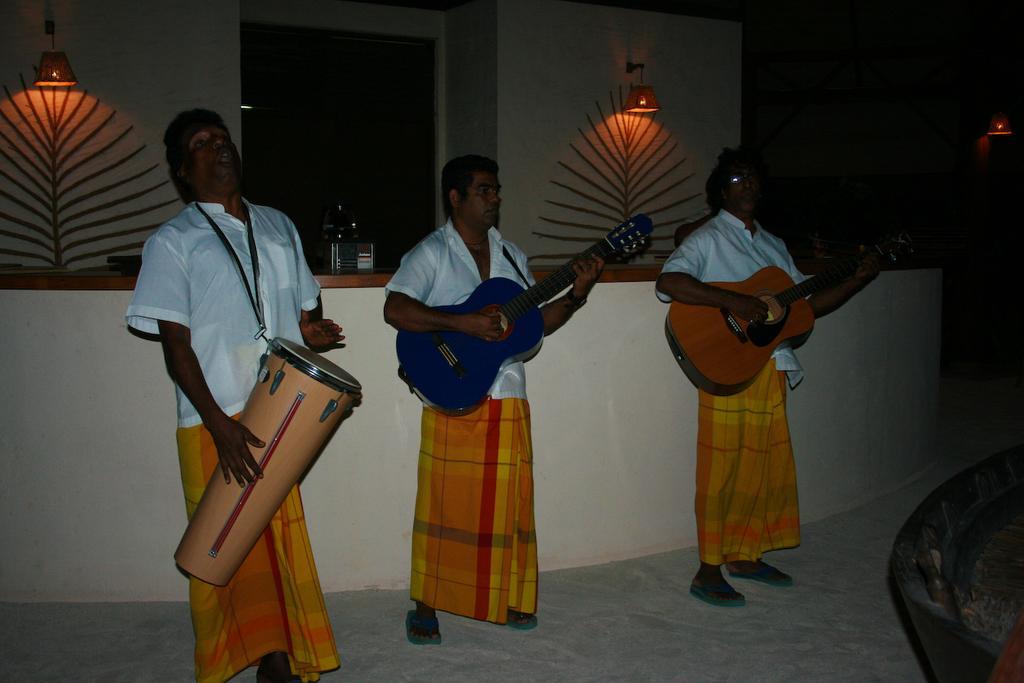How would you summarize this image in a sentence or two? A room with three people who wore same dress and holding some instruments i. e musical instruments and playing the instruments. Behind them we can see two lamps and a cardboard type desk behind them. 